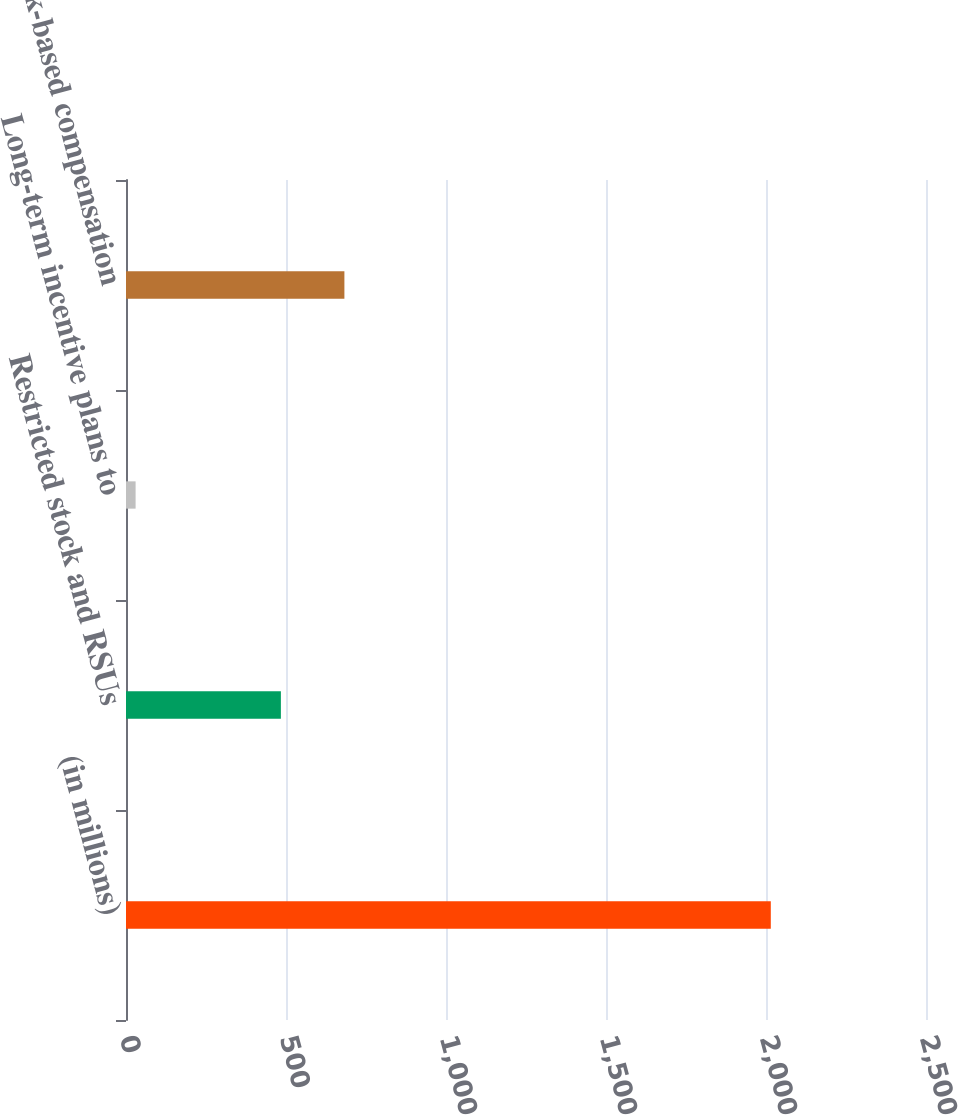Convert chart. <chart><loc_0><loc_0><loc_500><loc_500><bar_chart><fcel>(in millions)<fcel>Restricted stock and RSUs<fcel>Long-term incentive plans to<fcel>Total stock-based compensation<nl><fcel>2015<fcel>484<fcel>30<fcel>682.5<nl></chart> 